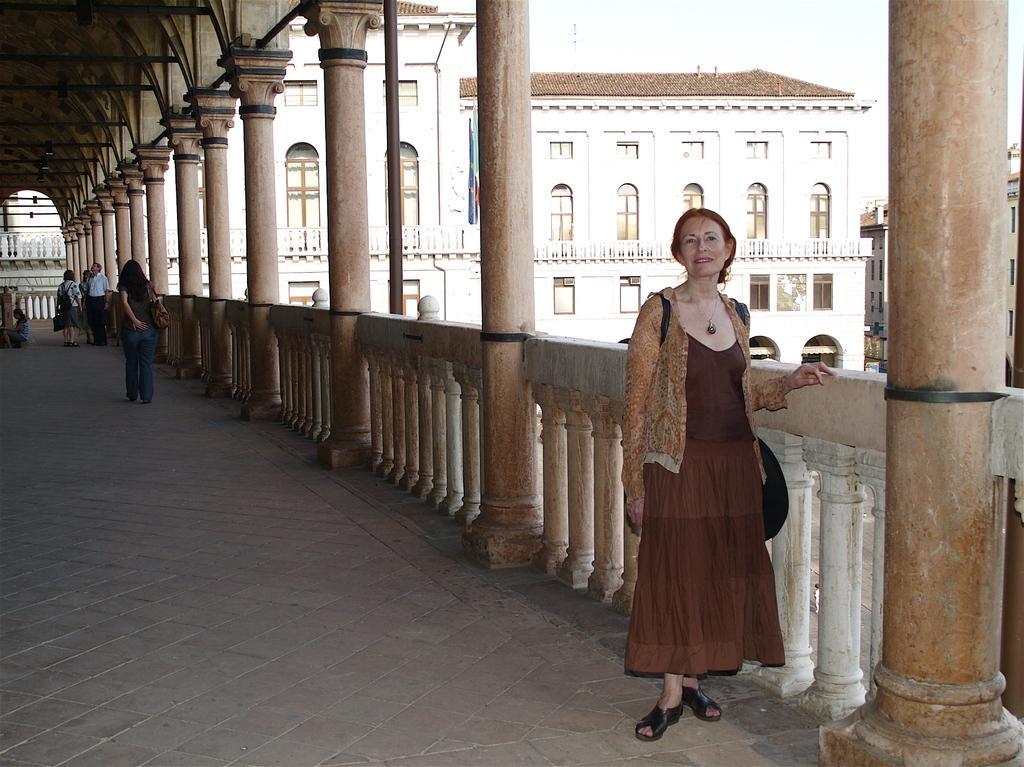In one or two sentences, can you explain what this image depicts? In this image we can see a balcony were people are standing. Behind the balcony buildings are present. To the right side of the image one lady is standing, she is carrying black color bag and wearing brown color dress. 